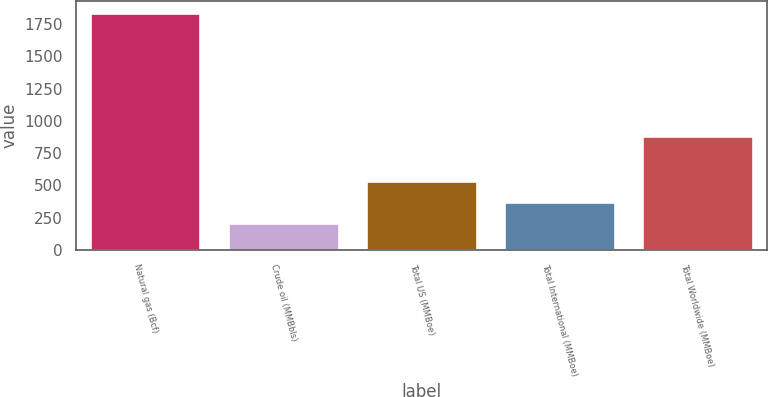Convert chart to OTSL. <chart><loc_0><loc_0><loc_500><loc_500><bar_chart><fcel>Natural gas (Bcf)<fcel>Crude oil (MMBbls)<fcel>Total US (MMBoe)<fcel>Total International (MMBoe)<fcel>Total Worldwide (MMBoe)<nl><fcel>1840<fcel>207<fcel>533.6<fcel>370.3<fcel>880<nl></chart> 